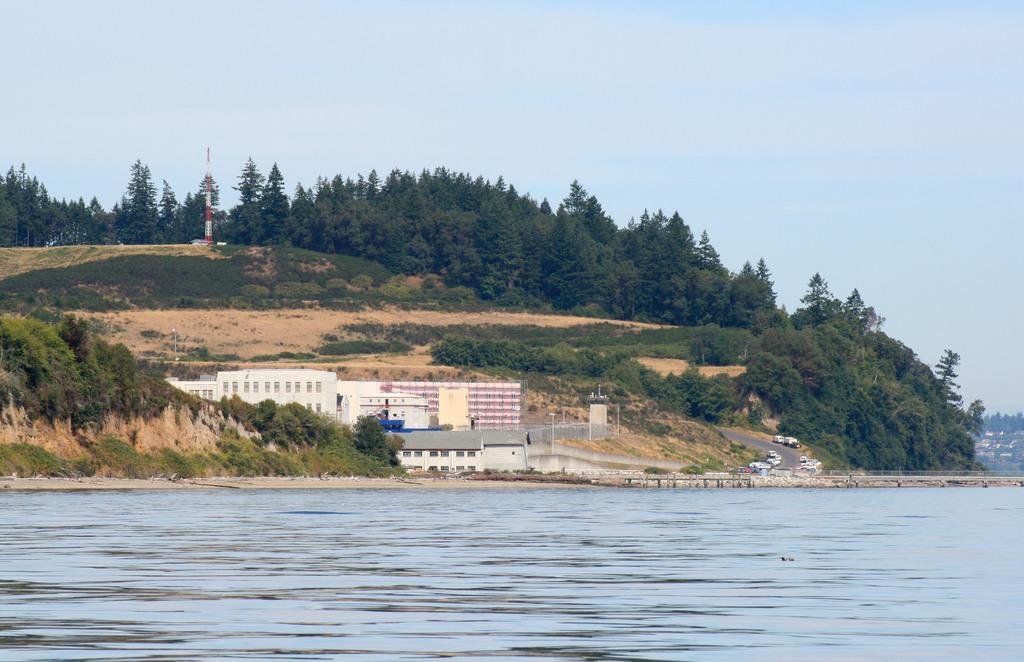Please provide a concise description of this image. In this image at the bottom there is a river, and in the center there are some buildings, trees, and plants and walkway and some vehicles, poles. And at the top there is sky. 